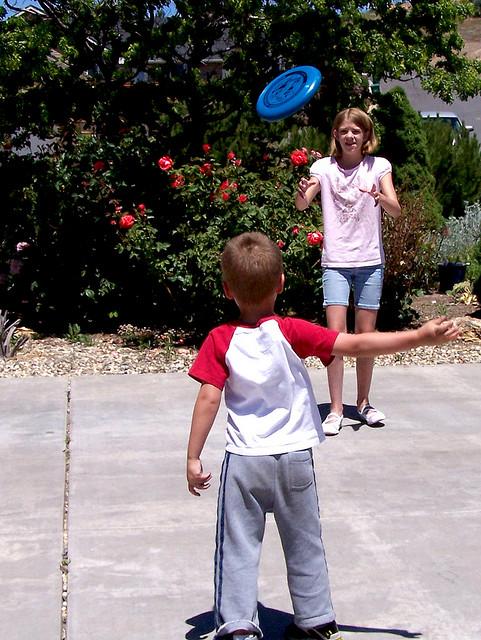Who threw the frisbee?
Short answer required. Boy. Where is the frisbee?
Quick response, please. Air. How many people are in the picture?
Give a very brief answer. 2. Did the person wearing shorts throw the frisbee?
Concise answer only. No. What is the boy learning?
Write a very short answer. Frisbee. What are the kids playing?
Concise answer only. Frisbee. Is the woman teaching the child how to play tennis?
Short answer required. No. How many shirts is the boy in front wearing?
Be succinct. 1. Is she wearing a sweatshirt?
Write a very short answer. No. What is this kid dressed for?
Be succinct. Play. What color is the Frisbee?
Keep it brief. Blue. Is he wearing blue jeans?
Write a very short answer. No. What game are these 2 about to play?
Quick response, please. Frisbee. Is this boy happy?
Write a very short answer. Yes. What is on the boy's hand?
Be succinct. Nothing. Is the boy alone?
Be succinct. No. 